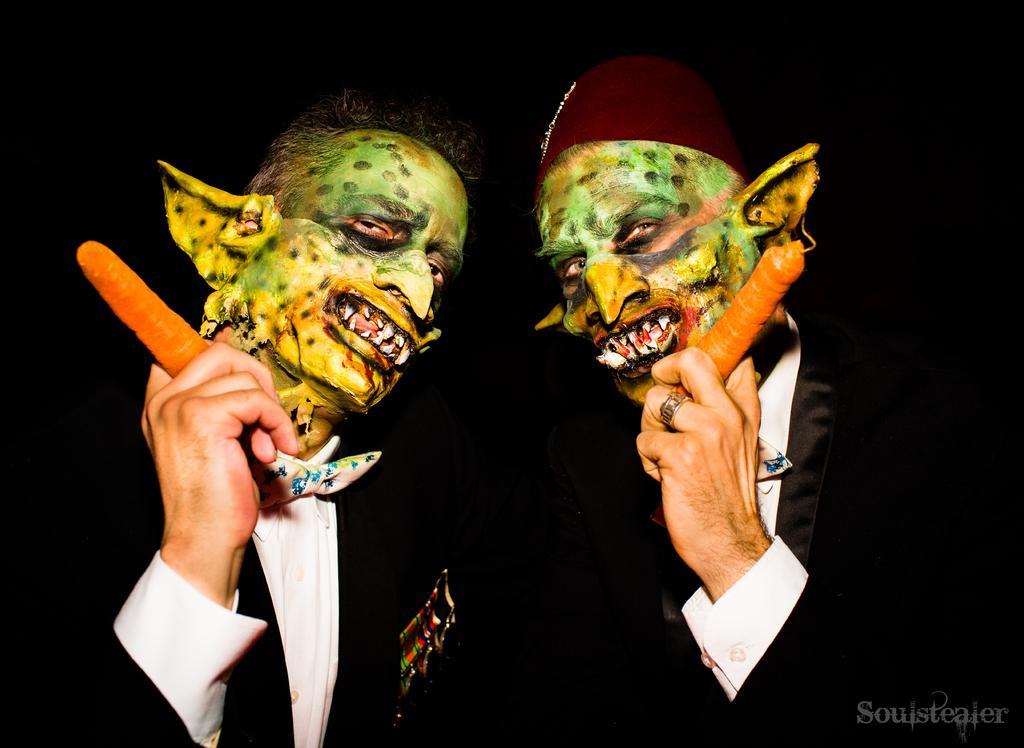Please provide a concise description of this image. In the image we can see there are two people standing and they have painted their face as monster. They are wearing formal suit and holding carrot in their hand. 